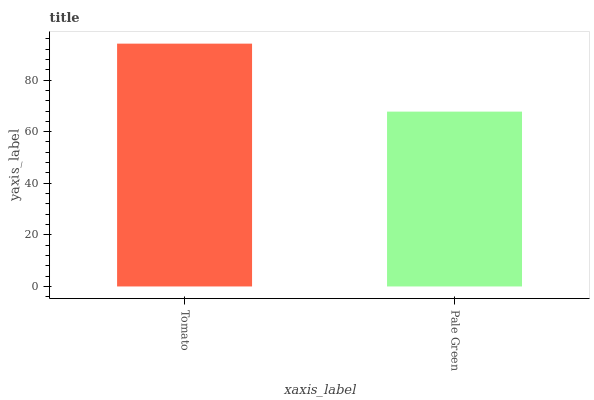Is Pale Green the minimum?
Answer yes or no. Yes. Is Tomato the maximum?
Answer yes or no. Yes. Is Pale Green the maximum?
Answer yes or no. No. Is Tomato greater than Pale Green?
Answer yes or no. Yes. Is Pale Green less than Tomato?
Answer yes or no. Yes. Is Pale Green greater than Tomato?
Answer yes or no. No. Is Tomato less than Pale Green?
Answer yes or no. No. Is Tomato the high median?
Answer yes or no. Yes. Is Pale Green the low median?
Answer yes or no. Yes. Is Pale Green the high median?
Answer yes or no. No. Is Tomato the low median?
Answer yes or no. No. 